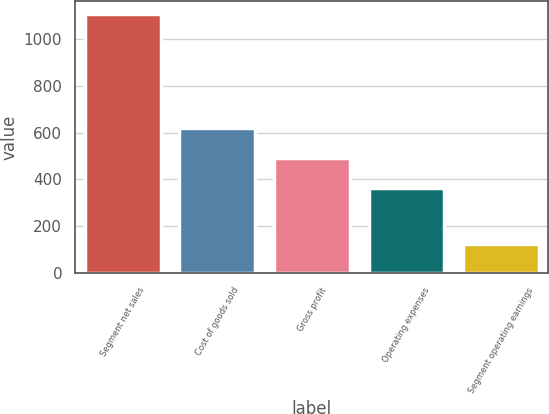Convert chart. <chart><loc_0><loc_0><loc_500><loc_500><bar_chart><fcel>Segment net sales<fcel>Cost of goods sold<fcel>Gross profit<fcel>Operating expenses<fcel>Segment operating earnings<nl><fcel>1107.7<fcel>618.2<fcel>489.5<fcel>364.4<fcel>125.1<nl></chart> 